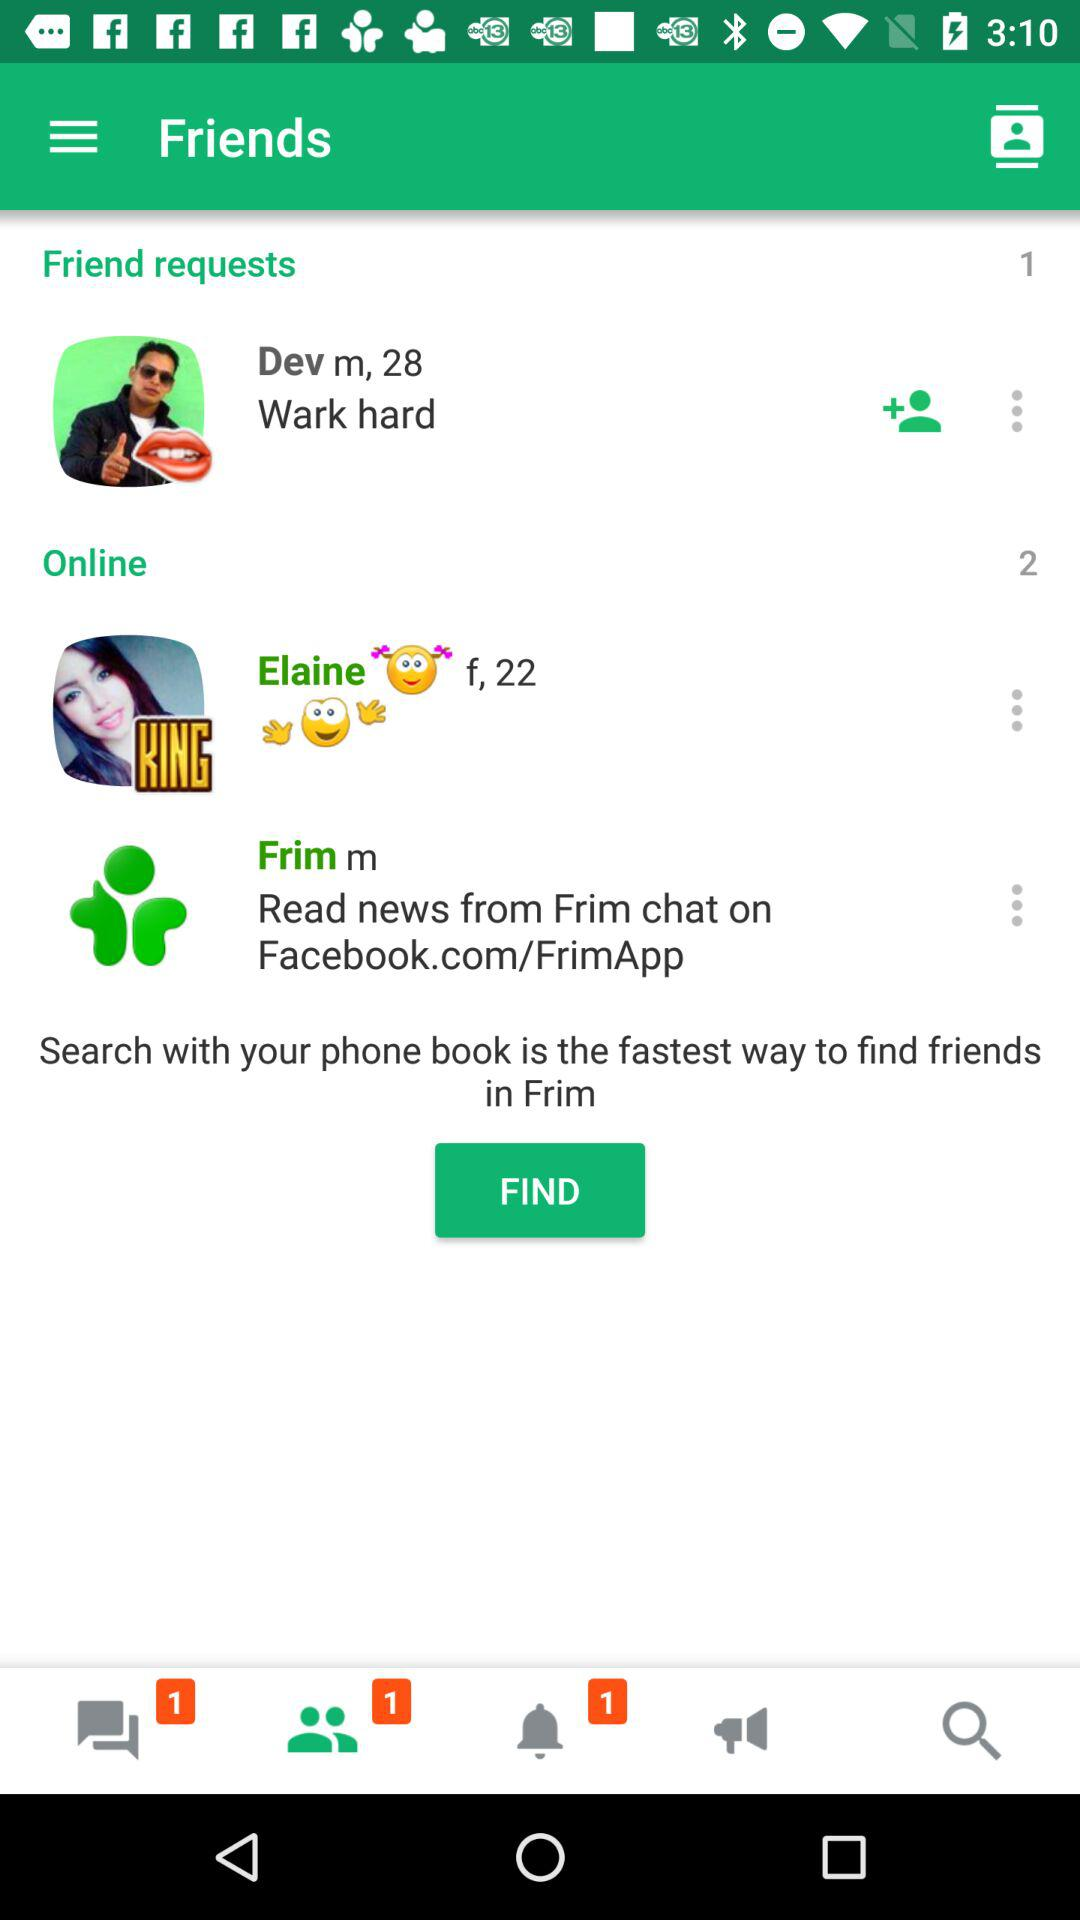What is the age of Dev? Dev is 28 years old. 